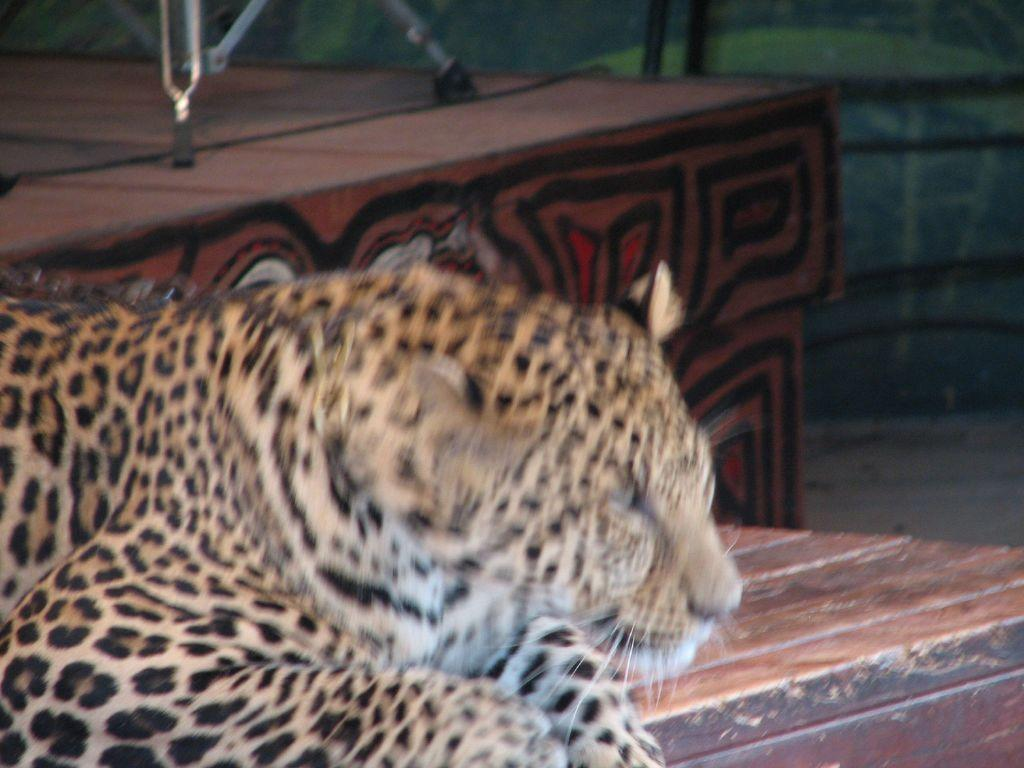What animal is in the image? There is a leopard in the image. Where is the leopard located? The leopard is on a table. What else can be seen in the image besides the leopard? There appears to be a stand in the image. What is visible in the background of the image? There are trees in the background of the image. What type of car can be seen in the image? There are no cars present in the image; it features a leopard on a table with a stand and trees in the background. What type of needle is being used by the leopard in the image? There is no needle present in the image, as it features a leopard on a table with a stand and trees in the background. 